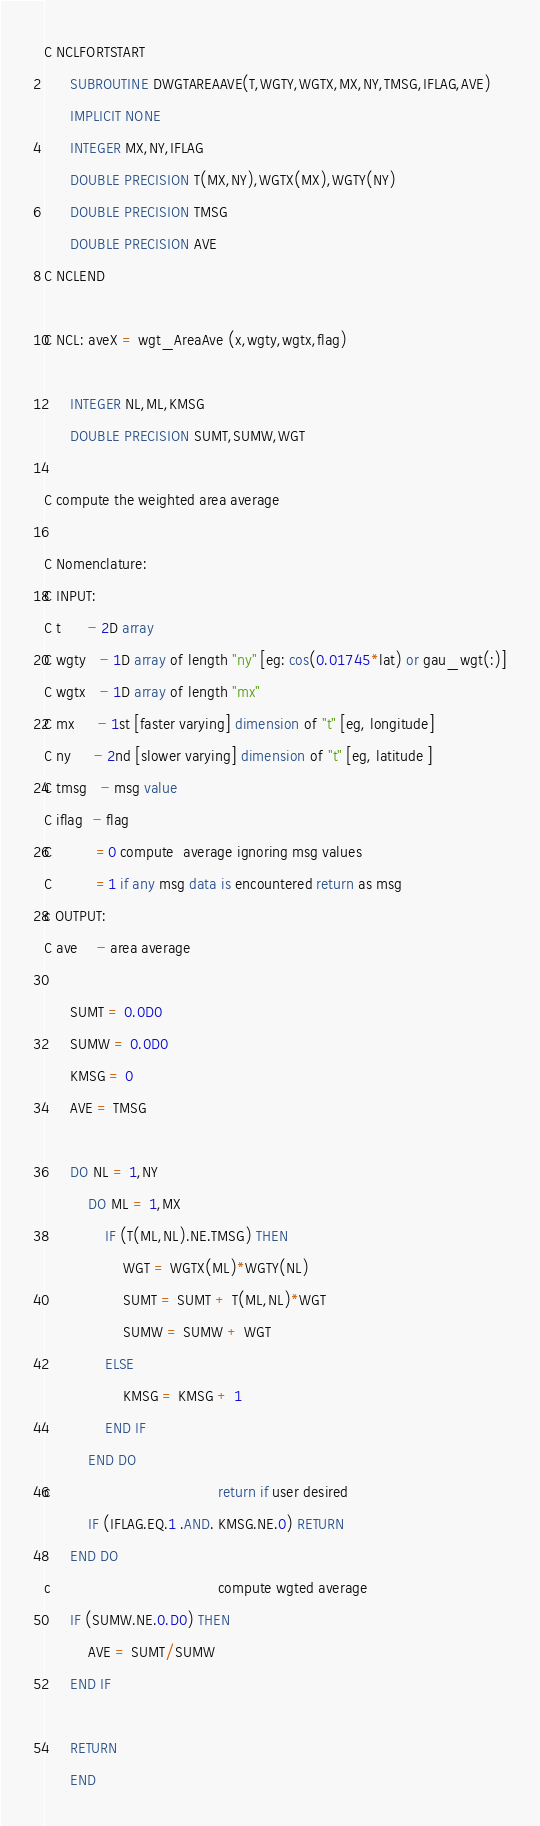Convert code to text. <code><loc_0><loc_0><loc_500><loc_500><_FORTRAN_>C NCLFORTSTART
      SUBROUTINE DWGTAREAAVE(T,WGTY,WGTX,MX,NY,TMSG,IFLAG,AVE)
      IMPLICIT NONE
      INTEGER MX,NY,IFLAG
      DOUBLE PRECISION T(MX,NY),WGTX(MX),WGTY(NY)
      DOUBLE PRECISION TMSG
      DOUBLE PRECISION AVE
C NCLEND

C NCL: aveX = wgt_AreaAve (x,wgty,wgtx,flag)

      INTEGER NL,ML,KMSG
      DOUBLE PRECISION SUMT,SUMW,WGT

C compute the weighted area average

C Nomenclature:
C INPUT:
C t      - 2D array
C wgty   - 1D array of length "ny" [eg: cos(0.01745*lat) or gau_wgt(:)]
C wgtx   - 1D array of length "mx"
C mx     - 1st [faster varying] dimension of "t" [eg, longitude]
C ny     - 2nd [slower varying] dimension of "t" [eg, latitude ]
C tmsg   - msg value
C iflag  - flag
C          =0 compute  average ignoring msg values
C          =1 if any msg data is encountered return as msg
c OUTPUT:
C ave    - area average

      SUMT = 0.0D0
      SUMW = 0.0D0
      KMSG = 0
      AVE = TMSG

      DO NL = 1,NY
          DO ML = 1,MX
              IF (T(ML,NL).NE.TMSG) THEN
                  WGT = WGTX(ML)*WGTY(NL)
                  SUMT = SUMT + T(ML,NL)*WGT
                  SUMW = SUMW + WGT
              ELSE
                  KMSG = KMSG + 1
              END IF
          END DO
c                                      return if user desired
          IF (IFLAG.EQ.1 .AND. KMSG.NE.0) RETURN
      END DO
c                                      compute wgted average
      IF (SUMW.NE.0.D0) THEN
          AVE = SUMT/SUMW
      END IF

      RETURN
      END
</code> 